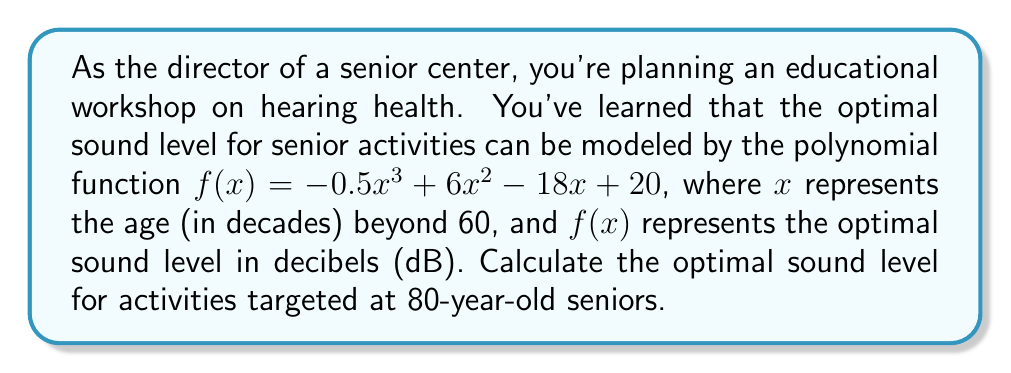Show me your answer to this math problem. To solve this problem, we need to follow these steps:

1) First, we need to determine the value of $x$ for 80-year-old seniors:
   80 years = 60 years + 20 years
   20 years = 2 decades
   So, $x = 2$

2) Now, we substitute $x = 2$ into the given polynomial function:

   $f(2) = -0.5(2)^3 + 6(2)^2 - 18(2) + 20$

3) Let's calculate each term:
   $-0.5(2)^3 = -0.5 * 8 = -4$
   $6(2)^2 = 6 * 4 = 24$
   $-18(2) = -36$
   $20$ remains as is

4) Now we add all these terms:

   $f(2) = -4 + 24 - 36 + 20 = 4$

Therefore, the optimal sound level for activities targeted at 80-year-old seniors is 4 dB.
Answer: 4 dB 